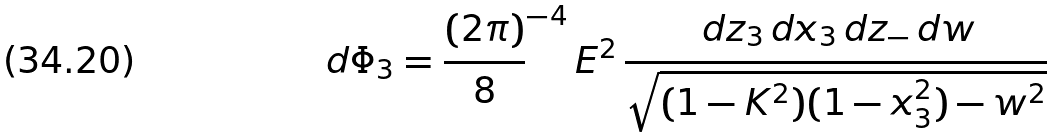Convert formula to latex. <formula><loc_0><loc_0><loc_500><loc_500>d \Phi _ { 3 } = \frac { ( 2 \pi ) } { 8 } ^ { - 4 } \, E ^ { 2 } \, \frac { \, d z _ { 3 } \, d x _ { 3 } \, d z _ { - } \, d w } { \sqrt { ( 1 - K ^ { 2 } ) ( 1 - x _ { 3 } ^ { 2 } ) - w ^ { 2 } } }</formula> 